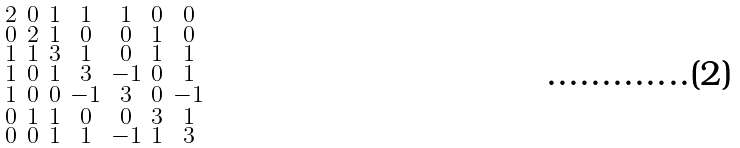Convert formula to latex. <formula><loc_0><loc_0><loc_500><loc_500>\begin{smallmatrix} 2 & 0 & 1 & 1 & 1 & 0 & 0 \\ 0 & 2 & 1 & 0 & 0 & 1 & 0 \\ 1 & 1 & 3 & 1 & 0 & 1 & 1 \\ 1 & 0 & 1 & 3 & - 1 & 0 & 1 \\ 1 & 0 & 0 & - 1 & 3 & 0 & - 1 \\ 0 & 1 & 1 & 0 & 0 & 3 & 1 \\ 0 & 0 & 1 & 1 & - 1 & 1 & 3 \end{smallmatrix}</formula> 